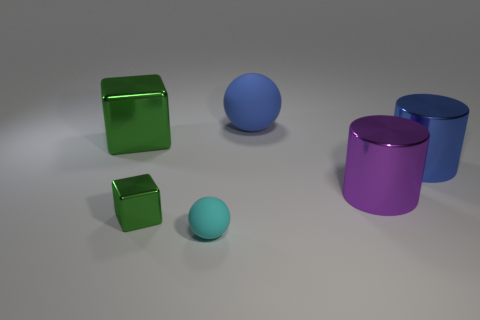Subtract all green blocks. How many were subtracted if there are1green blocks left? 1 Add 4 blue metal cylinders. How many objects exist? 10 Subtract all blocks. How many objects are left? 4 Add 6 small objects. How many small objects are left? 8 Add 3 tiny brown metallic things. How many tiny brown metallic things exist? 3 Subtract 0 green balls. How many objects are left? 6 Subtract all tiny cyan metallic blocks. Subtract all tiny green cubes. How many objects are left? 5 